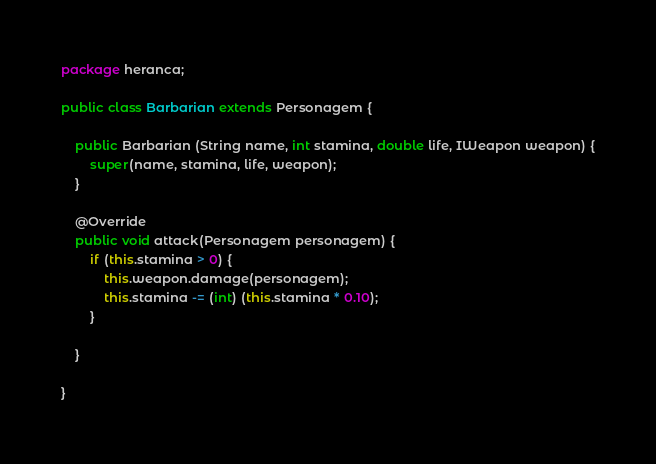Convert code to text. <code><loc_0><loc_0><loc_500><loc_500><_Java_>package heranca;

public class Barbarian extends Personagem {

    public Barbarian (String name, int stamina, double life, IWeapon weapon) {
        super(name, stamina, life, weapon);
    }

    @Override
    public void attack(Personagem personagem) {
        if (this.stamina > 0) {
            this.weapon.damage(personagem);
            this.stamina -= (int) (this.stamina * 0.10);
        }

    }

}
</code> 